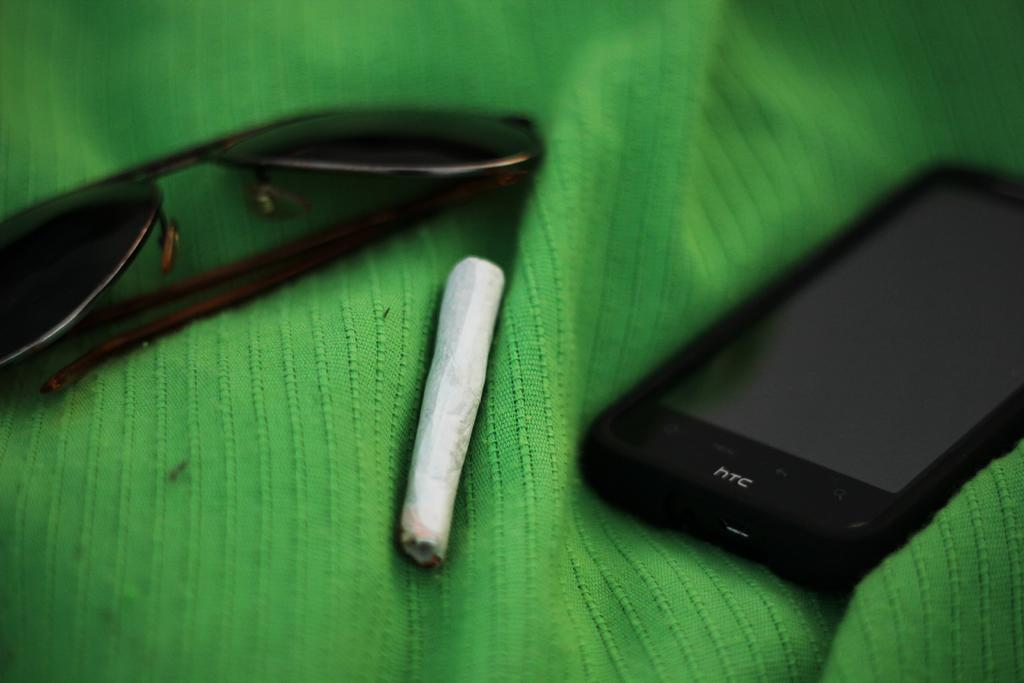<image>
Describe the image concisely. Black sunglasses, a rolled up cigarette and a hTc brand cellphone are on a green tarp 